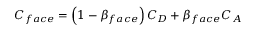Convert formula to latex. <formula><loc_0><loc_0><loc_500><loc_500>\begin{array} { r } { C _ { f a c e } = \left ( 1 - \beta _ { f a c e } \right ) C _ { D } + \beta _ { f a c e } C _ { A } } \end{array}</formula> 